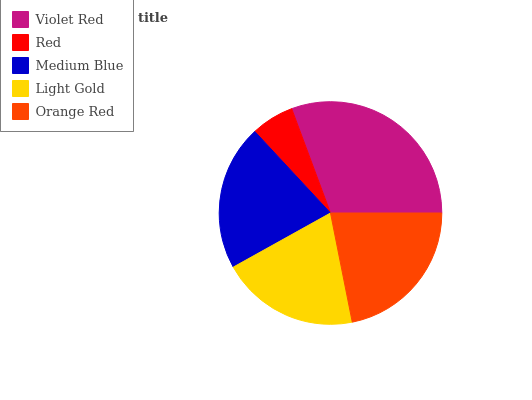Is Red the minimum?
Answer yes or no. Yes. Is Violet Red the maximum?
Answer yes or no. Yes. Is Medium Blue the minimum?
Answer yes or no. No. Is Medium Blue the maximum?
Answer yes or no. No. Is Medium Blue greater than Red?
Answer yes or no. Yes. Is Red less than Medium Blue?
Answer yes or no. Yes. Is Red greater than Medium Blue?
Answer yes or no. No. Is Medium Blue less than Red?
Answer yes or no. No. Is Medium Blue the high median?
Answer yes or no. Yes. Is Medium Blue the low median?
Answer yes or no. Yes. Is Red the high median?
Answer yes or no. No. Is Light Gold the low median?
Answer yes or no. No. 